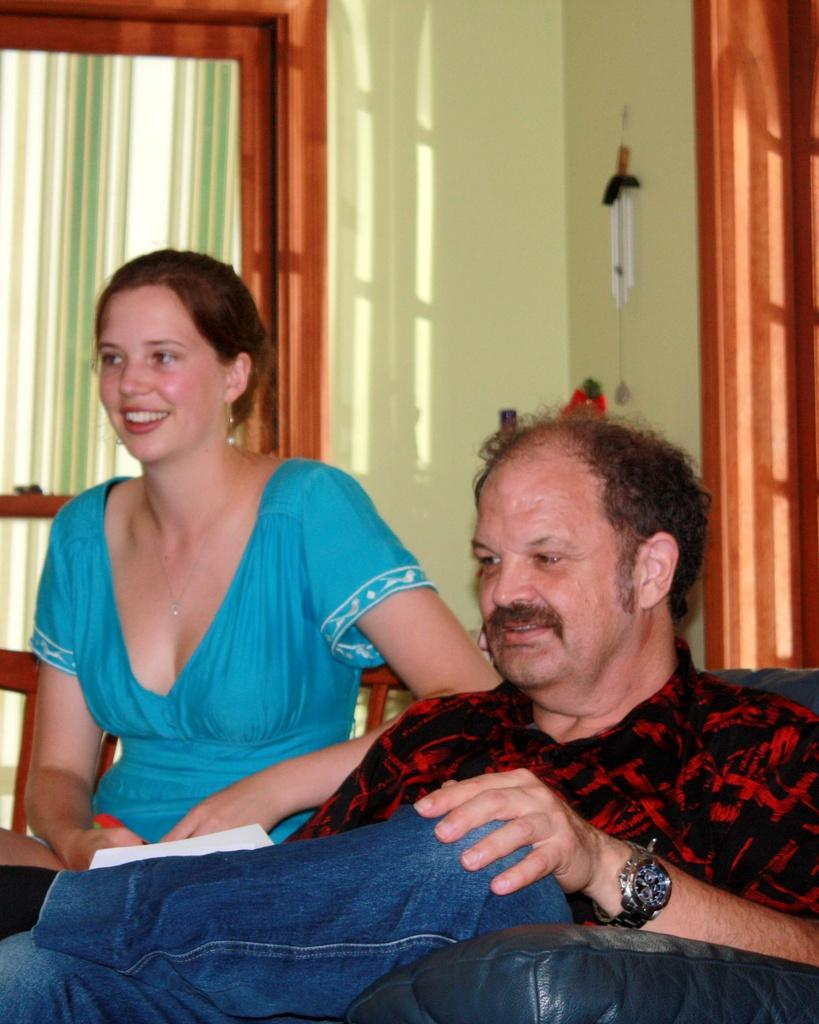How many people are sitting on the sofa in the image? There are two people sitting on the sofa in the image. What direction are the people watching? The people are watching towards the left hand side. What can be seen outside the window in the image? The facts provided do not give information about what can be seen outside the window. What architectural features areal features are present in the image? There is a door and a wall in the image. What type of decoration is hanging on the wall in the image? There is a wall hanging in the image. What type of sheet is covering the playground in the image? There is no playground or sheet present in the image. 